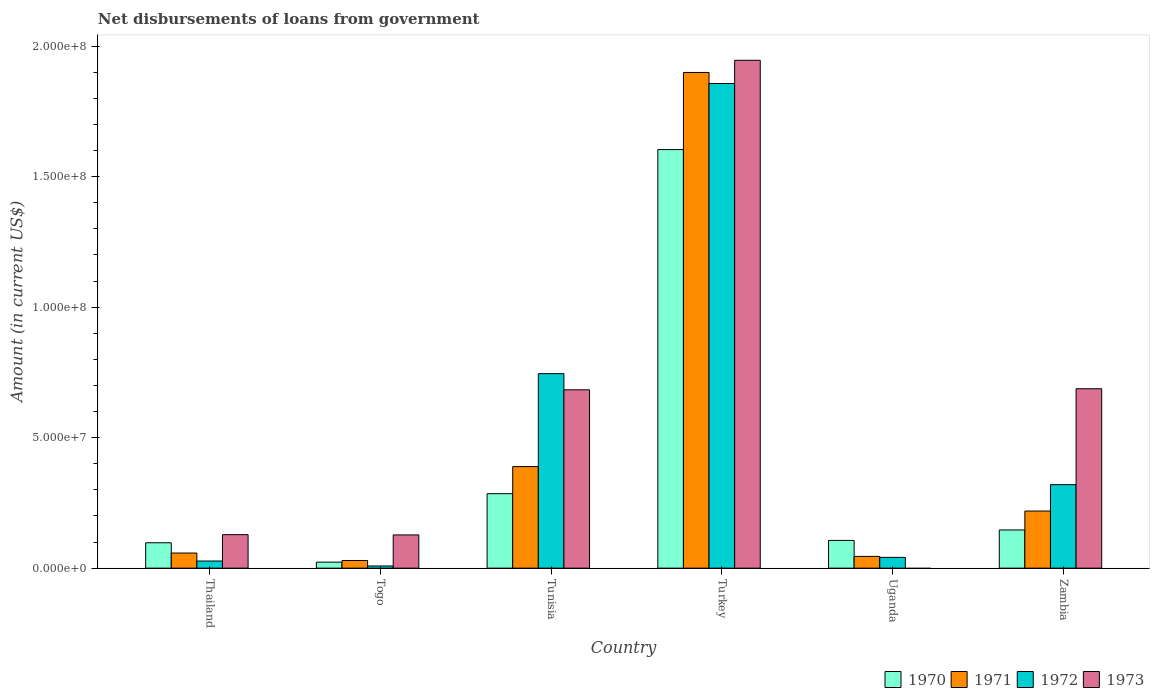How many different coloured bars are there?
Provide a short and direct response. 4. How many groups of bars are there?
Offer a terse response. 6. Are the number of bars per tick equal to the number of legend labels?
Provide a succinct answer. No. What is the label of the 6th group of bars from the left?
Make the answer very short. Zambia. What is the amount of loan disbursed from government in 1972 in Zambia?
Offer a very short reply. 3.20e+07. Across all countries, what is the maximum amount of loan disbursed from government in 1973?
Provide a succinct answer. 1.95e+08. Across all countries, what is the minimum amount of loan disbursed from government in 1970?
Provide a succinct answer. 2.30e+06. What is the total amount of loan disbursed from government in 1972 in the graph?
Provide a succinct answer. 3.00e+08. What is the difference between the amount of loan disbursed from government in 1972 in Thailand and that in Uganda?
Ensure brevity in your answer.  -1.40e+06. What is the difference between the amount of loan disbursed from government in 1971 in Togo and the amount of loan disbursed from government in 1972 in Zambia?
Provide a short and direct response. -2.91e+07. What is the average amount of loan disbursed from government in 1970 per country?
Provide a short and direct response. 3.77e+07. What is the difference between the amount of loan disbursed from government of/in 1972 and amount of loan disbursed from government of/in 1971 in Zambia?
Offer a very short reply. 1.01e+07. What is the ratio of the amount of loan disbursed from government in 1970 in Togo to that in Uganda?
Ensure brevity in your answer.  0.22. Is the difference between the amount of loan disbursed from government in 1972 in Tunisia and Zambia greater than the difference between the amount of loan disbursed from government in 1971 in Tunisia and Zambia?
Your answer should be very brief. Yes. What is the difference between the highest and the second highest amount of loan disbursed from government in 1973?
Make the answer very short. 1.26e+08. What is the difference between the highest and the lowest amount of loan disbursed from government in 1972?
Provide a succinct answer. 1.85e+08. In how many countries, is the amount of loan disbursed from government in 1971 greater than the average amount of loan disbursed from government in 1971 taken over all countries?
Keep it short and to the point. 1. Is the sum of the amount of loan disbursed from government in 1972 in Togo and Turkey greater than the maximum amount of loan disbursed from government in 1971 across all countries?
Offer a terse response. No. Is it the case that in every country, the sum of the amount of loan disbursed from government in 1971 and amount of loan disbursed from government in 1973 is greater than the sum of amount of loan disbursed from government in 1972 and amount of loan disbursed from government in 1970?
Your response must be concise. No. Is it the case that in every country, the sum of the amount of loan disbursed from government in 1972 and amount of loan disbursed from government in 1973 is greater than the amount of loan disbursed from government in 1971?
Make the answer very short. No. How many bars are there?
Keep it short and to the point. 23. How many countries are there in the graph?
Give a very brief answer. 6. Does the graph contain grids?
Ensure brevity in your answer.  No. How many legend labels are there?
Your response must be concise. 4. What is the title of the graph?
Keep it short and to the point. Net disbursements of loans from government. What is the label or title of the X-axis?
Offer a terse response. Country. What is the Amount (in current US$) in 1970 in Thailand?
Your answer should be very brief. 9.73e+06. What is the Amount (in current US$) in 1971 in Thailand?
Offer a very short reply. 5.79e+06. What is the Amount (in current US$) of 1972 in Thailand?
Provide a succinct answer. 2.73e+06. What is the Amount (in current US$) of 1973 in Thailand?
Ensure brevity in your answer.  1.28e+07. What is the Amount (in current US$) of 1970 in Togo?
Your response must be concise. 2.30e+06. What is the Amount (in current US$) of 1971 in Togo?
Provide a short and direct response. 2.94e+06. What is the Amount (in current US$) in 1972 in Togo?
Give a very brief answer. 8.31e+05. What is the Amount (in current US$) in 1973 in Togo?
Provide a succinct answer. 1.27e+07. What is the Amount (in current US$) of 1970 in Tunisia?
Your answer should be compact. 2.85e+07. What is the Amount (in current US$) in 1971 in Tunisia?
Offer a terse response. 3.89e+07. What is the Amount (in current US$) of 1972 in Tunisia?
Ensure brevity in your answer.  7.45e+07. What is the Amount (in current US$) of 1973 in Tunisia?
Provide a short and direct response. 6.83e+07. What is the Amount (in current US$) in 1970 in Turkey?
Offer a terse response. 1.60e+08. What is the Amount (in current US$) in 1971 in Turkey?
Provide a short and direct response. 1.90e+08. What is the Amount (in current US$) of 1972 in Turkey?
Keep it short and to the point. 1.86e+08. What is the Amount (in current US$) of 1973 in Turkey?
Provide a short and direct response. 1.95e+08. What is the Amount (in current US$) in 1970 in Uganda?
Provide a short and direct response. 1.06e+07. What is the Amount (in current US$) of 1971 in Uganda?
Offer a very short reply. 4.51e+06. What is the Amount (in current US$) of 1972 in Uganda?
Offer a terse response. 4.13e+06. What is the Amount (in current US$) of 1970 in Zambia?
Your answer should be compact. 1.46e+07. What is the Amount (in current US$) in 1971 in Zambia?
Your response must be concise. 2.19e+07. What is the Amount (in current US$) in 1972 in Zambia?
Provide a succinct answer. 3.20e+07. What is the Amount (in current US$) in 1973 in Zambia?
Provide a succinct answer. 6.88e+07. Across all countries, what is the maximum Amount (in current US$) of 1970?
Offer a terse response. 1.60e+08. Across all countries, what is the maximum Amount (in current US$) in 1971?
Offer a very short reply. 1.90e+08. Across all countries, what is the maximum Amount (in current US$) of 1972?
Give a very brief answer. 1.86e+08. Across all countries, what is the maximum Amount (in current US$) of 1973?
Your answer should be compact. 1.95e+08. Across all countries, what is the minimum Amount (in current US$) in 1970?
Give a very brief answer. 2.30e+06. Across all countries, what is the minimum Amount (in current US$) of 1971?
Offer a very short reply. 2.94e+06. Across all countries, what is the minimum Amount (in current US$) in 1972?
Offer a terse response. 8.31e+05. What is the total Amount (in current US$) of 1970 in the graph?
Make the answer very short. 2.26e+08. What is the total Amount (in current US$) of 1971 in the graph?
Your answer should be compact. 2.64e+08. What is the total Amount (in current US$) of 1972 in the graph?
Make the answer very short. 3.00e+08. What is the total Amount (in current US$) of 1973 in the graph?
Your answer should be very brief. 3.57e+08. What is the difference between the Amount (in current US$) of 1970 in Thailand and that in Togo?
Offer a terse response. 7.43e+06. What is the difference between the Amount (in current US$) in 1971 in Thailand and that in Togo?
Make the answer very short. 2.85e+06. What is the difference between the Amount (in current US$) of 1972 in Thailand and that in Togo?
Provide a short and direct response. 1.90e+06. What is the difference between the Amount (in current US$) of 1973 in Thailand and that in Togo?
Your answer should be very brief. 9.30e+04. What is the difference between the Amount (in current US$) of 1970 in Thailand and that in Tunisia?
Keep it short and to the point. -1.88e+07. What is the difference between the Amount (in current US$) in 1971 in Thailand and that in Tunisia?
Make the answer very short. -3.31e+07. What is the difference between the Amount (in current US$) of 1972 in Thailand and that in Tunisia?
Ensure brevity in your answer.  -7.18e+07. What is the difference between the Amount (in current US$) of 1973 in Thailand and that in Tunisia?
Your response must be concise. -5.55e+07. What is the difference between the Amount (in current US$) in 1970 in Thailand and that in Turkey?
Keep it short and to the point. -1.51e+08. What is the difference between the Amount (in current US$) in 1971 in Thailand and that in Turkey?
Your response must be concise. -1.84e+08. What is the difference between the Amount (in current US$) in 1972 in Thailand and that in Turkey?
Provide a succinct answer. -1.83e+08. What is the difference between the Amount (in current US$) of 1973 in Thailand and that in Turkey?
Your answer should be compact. -1.82e+08. What is the difference between the Amount (in current US$) in 1970 in Thailand and that in Uganda?
Provide a succinct answer. -8.97e+05. What is the difference between the Amount (in current US$) in 1971 in Thailand and that in Uganda?
Give a very brief answer. 1.28e+06. What is the difference between the Amount (in current US$) of 1972 in Thailand and that in Uganda?
Keep it short and to the point. -1.40e+06. What is the difference between the Amount (in current US$) of 1970 in Thailand and that in Zambia?
Offer a terse response. -4.90e+06. What is the difference between the Amount (in current US$) in 1971 in Thailand and that in Zambia?
Offer a very short reply. -1.61e+07. What is the difference between the Amount (in current US$) of 1972 in Thailand and that in Zambia?
Ensure brevity in your answer.  -2.93e+07. What is the difference between the Amount (in current US$) in 1973 in Thailand and that in Zambia?
Your answer should be compact. -5.59e+07. What is the difference between the Amount (in current US$) in 1970 in Togo and that in Tunisia?
Ensure brevity in your answer.  -2.62e+07. What is the difference between the Amount (in current US$) of 1971 in Togo and that in Tunisia?
Your answer should be very brief. -3.60e+07. What is the difference between the Amount (in current US$) of 1972 in Togo and that in Tunisia?
Ensure brevity in your answer.  -7.37e+07. What is the difference between the Amount (in current US$) in 1973 in Togo and that in Tunisia?
Provide a succinct answer. -5.56e+07. What is the difference between the Amount (in current US$) in 1970 in Togo and that in Turkey?
Your answer should be compact. -1.58e+08. What is the difference between the Amount (in current US$) in 1971 in Togo and that in Turkey?
Offer a terse response. -1.87e+08. What is the difference between the Amount (in current US$) in 1972 in Togo and that in Turkey?
Your response must be concise. -1.85e+08. What is the difference between the Amount (in current US$) in 1973 in Togo and that in Turkey?
Provide a succinct answer. -1.82e+08. What is the difference between the Amount (in current US$) of 1970 in Togo and that in Uganda?
Your answer should be very brief. -8.33e+06. What is the difference between the Amount (in current US$) of 1971 in Togo and that in Uganda?
Make the answer very short. -1.57e+06. What is the difference between the Amount (in current US$) in 1972 in Togo and that in Uganda?
Offer a very short reply. -3.30e+06. What is the difference between the Amount (in current US$) in 1970 in Togo and that in Zambia?
Ensure brevity in your answer.  -1.23e+07. What is the difference between the Amount (in current US$) in 1971 in Togo and that in Zambia?
Offer a terse response. -1.89e+07. What is the difference between the Amount (in current US$) in 1972 in Togo and that in Zambia?
Offer a very short reply. -3.12e+07. What is the difference between the Amount (in current US$) in 1973 in Togo and that in Zambia?
Your answer should be compact. -5.60e+07. What is the difference between the Amount (in current US$) in 1970 in Tunisia and that in Turkey?
Your answer should be compact. -1.32e+08. What is the difference between the Amount (in current US$) of 1971 in Tunisia and that in Turkey?
Make the answer very short. -1.51e+08. What is the difference between the Amount (in current US$) of 1972 in Tunisia and that in Turkey?
Offer a very short reply. -1.11e+08. What is the difference between the Amount (in current US$) in 1973 in Tunisia and that in Turkey?
Ensure brevity in your answer.  -1.26e+08. What is the difference between the Amount (in current US$) of 1970 in Tunisia and that in Uganda?
Offer a terse response. 1.79e+07. What is the difference between the Amount (in current US$) in 1971 in Tunisia and that in Uganda?
Provide a short and direct response. 3.44e+07. What is the difference between the Amount (in current US$) of 1972 in Tunisia and that in Uganda?
Your answer should be very brief. 7.04e+07. What is the difference between the Amount (in current US$) in 1970 in Tunisia and that in Zambia?
Ensure brevity in your answer.  1.39e+07. What is the difference between the Amount (in current US$) in 1971 in Tunisia and that in Zambia?
Provide a short and direct response. 1.70e+07. What is the difference between the Amount (in current US$) in 1972 in Tunisia and that in Zambia?
Offer a very short reply. 4.25e+07. What is the difference between the Amount (in current US$) of 1973 in Tunisia and that in Zambia?
Ensure brevity in your answer.  -4.12e+05. What is the difference between the Amount (in current US$) in 1970 in Turkey and that in Uganda?
Offer a very short reply. 1.50e+08. What is the difference between the Amount (in current US$) of 1971 in Turkey and that in Uganda?
Offer a very short reply. 1.85e+08. What is the difference between the Amount (in current US$) of 1972 in Turkey and that in Uganda?
Your answer should be very brief. 1.82e+08. What is the difference between the Amount (in current US$) in 1970 in Turkey and that in Zambia?
Offer a very short reply. 1.46e+08. What is the difference between the Amount (in current US$) of 1971 in Turkey and that in Zambia?
Your answer should be very brief. 1.68e+08. What is the difference between the Amount (in current US$) of 1972 in Turkey and that in Zambia?
Make the answer very short. 1.54e+08. What is the difference between the Amount (in current US$) in 1973 in Turkey and that in Zambia?
Your response must be concise. 1.26e+08. What is the difference between the Amount (in current US$) in 1970 in Uganda and that in Zambia?
Ensure brevity in your answer.  -4.01e+06. What is the difference between the Amount (in current US$) of 1971 in Uganda and that in Zambia?
Provide a succinct answer. -1.74e+07. What is the difference between the Amount (in current US$) of 1972 in Uganda and that in Zambia?
Offer a very short reply. -2.79e+07. What is the difference between the Amount (in current US$) in 1970 in Thailand and the Amount (in current US$) in 1971 in Togo?
Give a very brief answer. 6.80e+06. What is the difference between the Amount (in current US$) of 1970 in Thailand and the Amount (in current US$) of 1972 in Togo?
Offer a terse response. 8.90e+06. What is the difference between the Amount (in current US$) in 1970 in Thailand and the Amount (in current US$) in 1973 in Togo?
Provide a short and direct response. -3.00e+06. What is the difference between the Amount (in current US$) of 1971 in Thailand and the Amount (in current US$) of 1972 in Togo?
Make the answer very short. 4.96e+06. What is the difference between the Amount (in current US$) of 1971 in Thailand and the Amount (in current US$) of 1973 in Togo?
Provide a short and direct response. -6.95e+06. What is the difference between the Amount (in current US$) in 1972 in Thailand and the Amount (in current US$) in 1973 in Togo?
Your answer should be very brief. -1.00e+07. What is the difference between the Amount (in current US$) in 1970 in Thailand and the Amount (in current US$) in 1971 in Tunisia?
Offer a very short reply. -2.92e+07. What is the difference between the Amount (in current US$) of 1970 in Thailand and the Amount (in current US$) of 1972 in Tunisia?
Make the answer very short. -6.48e+07. What is the difference between the Amount (in current US$) in 1970 in Thailand and the Amount (in current US$) in 1973 in Tunisia?
Give a very brief answer. -5.86e+07. What is the difference between the Amount (in current US$) of 1971 in Thailand and the Amount (in current US$) of 1972 in Tunisia?
Your answer should be very brief. -6.87e+07. What is the difference between the Amount (in current US$) of 1971 in Thailand and the Amount (in current US$) of 1973 in Tunisia?
Offer a very short reply. -6.26e+07. What is the difference between the Amount (in current US$) of 1972 in Thailand and the Amount (in current US$) of 1973 in Tunisia?
Offer a very short reply. -6.56e+07. What is the difference between the Amount (in current US$) of 1970 in Thailand and the Amount (in current US$) of 1971 in Turkey?
Offer a very short reply. -1.80e+08. What is the difference between the Amount (in current US$) of 1970 in Thailand and the Amount (in current US$) of 1972 in Turkey?
Your answer should be very brief. -1.76e+08. What is the difference between the Amount (in current US$) of 1970 in Thailand and the Amount (in current US$) of 1973 in Turkey?
Provide a short and direct response. -1.85e+08. What is the difference between the Amount (in current US$) in 1971 in Thailand and the Amount (in current US$) in 1972 in Turkey?
Offer a terse response. -1.80e+08. What is the difference between the Amount (in current US$) of 1971 in Thailand and the Amount (in current US$) of 1973 in Turkey?
Offer a terse response. -1.89e+08. What is the difference between the Amount (in current US$) of 1972 in Thailand and the Amount (in current US$) of 1973 in Turkey?
Offer a very short reply. -1.92e+08. What is the difference between the Amount (in current US$) in 1970 in Thailand and the Amount (in current US$) in 1971 in Uganda?
Give a very brief answer. 5.22e+06. What is the difference between the Amount (in current US$) of 1970 in Thailand and the Amount (in current US$) of 1972 in Uganda?
Your answer should be very brief. 5.60e+06. What is the difference between the Amount (in current US$) of 1971 in Thailand and the Amount (in current US$) of 1972 in Uganda?
Provide a succinct answer. 1.66e+06. What is the difference between the Amount (in current US$) in 1970 in Thailand and the Amount (in current US$) in 1971 in Zambia?
Make the answer very short. -1.22e+07. What is the difference between the Amount (in current US$) of 1970 in Thailand and the Amount (in current US$) of 1972 in Zambia?
Make the answer very short. -2.23e+07. What is the difference between the Amount (in current US$) of 1970 in Thailand and the Amount (in current US$) of 1973 in Zambia?
Keep it short and to the point. -5.90e+07. What is the difference between the Amount (in current US$) of 1971 in Thailand and the Amount (in current US$) of 1972 in Zambia?
Make the answer very short. -2.62e+07. What is the difference between the Amount (in current US$) of 1971 in Thailand and the Amount (in current US$) of 1973 in Zambia?
Provide a succinct answer. -6.30e+07. What is the difference between the Amount (in current US$) in 1972 in Thailand and the Amount (in current US$) in 1973 in Zambia?
Provide a short and direct response. -6.60e+07. What is the difference between the Amount (in current US$) of 1970 in Togo and the Amount (in current US$) of 1971 in Tunisia?
Offer a very short reply. -3.66e+07. What is the difference between the Amount (in current US$) of 1970 in Togo and the Amount (in current US$) of 1972 in Tunisia?
Keep it short and to the point. -7.22e+07. What is the difference between the Amount (in current US$) in 1970 in Togo and the Amount (in current US$) in 1973 in Tunisia?
Your response must be concise. -6.60e+07. What is the difference between the Amount (in current US$) in 1971 in Togo and the Amount (in current US$) in 1972 in Tunisia?
Offer a very short reply. -7.16e+07. What is the difference between the Amount (in current US$) of 1971 in Togo and the Amount (in current US$) of 1973 in Tunisia?
Give a very brief answer. -6.54e+07. What is the difference between the Amount (in current US$) of 1972 in Togo and the Amount (in current US$) of 1973 in Tunisia?
Offer a terse response. -6.75e+07. What is the difference between the Amount (in current US$) of 1970 in Togo and the Amount (in current US$) of 1971 in Turkey?
Provide a short and direct response. -1.88e+08. What is the difference between the Amount (in current US$) in 1970 in Togo and the Amount (in current US$) in 1972 in Turkey?
Ensure brevity in your answer.  -1.83e+08. What is the difference between the Amount (in current US$) of 1970 in Togo and the Amount (in current US$) of 1973 in Turkey?
Offer a terse response. -1.92e+08. What is the difference between the Amount (in current US$) of 1971 in Togo and the Amount (in current US$) of 1972 in Turkey?
Make the answer very short. -1.83e+08. What is the difference between the Amount (in current US$) in 1971 in Togo and the Amount (in current US$) in 1973 in Turkey?
Provide a short and direct response. -1.92e+08. What is the difference between the Amount (in current US$) of 1972 in Togo and the Amount (in current US$) of 1973 in Turkey?
Your answer should be very brief. -1.94e+08. What is the difference between the Amount (in current US$) in 1970 in Togo and the Amount (in current US$) in 1971 in Uganda?
Ensure brevity in your answer.  -2.21e+06. What is the difference between the Amount (in current US$) in 1970 in Togo and the Amount (in current US$) in 1972 in Uganda?
Offer a very short reply. -1.83e+06. What is the difference between the Amount (in current US$) of 1971 in Togo and the Amount (in current US$) of 1972 in Uganda?
Give a very brief answer. -1.20e+06. What is the difference between the Amount (in current US$) of 1970 in Togo and the Amount (in current US$) of 1971 in Zambia?
Make the answer very short. -1.96e+07. What is the difference between the Amount (in current US$) in 1970 in Togo and the Amount (in current US$) in 1972 in Zambia?
Provide a succinct answer. -2.97e+07. What is the difference between the Amount (in current US$) in 1970 in Togo and the Amount (in current US$) in 1973 in Zambia?
Give a very brief answer. -6.65e+07. What is the difference between the Amount (in current US$) of 1971 in Togo and the Amount (in current US$) of 1972 in Zambia?
Offer a very short reply. -2.91e+07. What is the difference between the Amount (in current US$) in 1971 in Togo and the Amount (in current US$) in 1973 in Zambia?
Ensure brevity in your answer.  -6.58e+07. What is the difference between the Amount (in current US$) in 1972 in Togo and the Amount (in current US$) in 1973 in Zambia?
Make the answer very short. -6.79e+07. What is the difference between the Amount (in current US$) in 1970 in Tunisia and the Amount (in current US$) in 1971 in Turkey?
Make the answer very short. -1.61e+08. What is the difference between the Amount (in current US$) of 1970 in Tunisia and the Amount (in current US$) of 1972 in Turkey?
Offer a terse response. -1.57e+08. What is the difference between the Amount (in current US$) of 1970 in Tunisia and the Amount (in current US$) of 1973 in Turkey?
Make the answer very short. -1.66e+08. What is the difference between the Amount (in current US$) of 1971 in Tunisia and the Amount (in current US$) of 1972 in Turkey?
Provide a short and direct response. -1.47e+08. What is the difference between the Amount (in current US$) in 1971 in Tunisia and the Amount (in current US$) in 1973 in Turkey?
Your response must be concise. -1.56e+08. What is the difference between the Amount (in current US$) in 1972 in Tunisia and the Amount (in current US$) in 1973 in Turkey?
Ensure brevity in your answer.  -1.20e+08. What is the difference between the Amount (in current US$) in 1970 in Tunisia and the Amount (in current US$) in 1971 in Uganda?
Keep it short and to the point. 2.40e+07. What is the difference between the Amount (in current US$) of 1970 in Tunisia and the Amount (in current US$) of 1972 in Uganda?
Give a very brief answer. 2.44e+07. What is the difference between the Amount (in current US$) of 1971 in Tunisia and the Amount (in current US$) of 1972 in Uganda?
Offer a terse response. 3.48e+07. What is the difference between the Amount (in current US$) of 1970 in Tunisia and the Amount (in current US$) of 1971 in Zambia?
Offer a terse response. 6.66e+06. What is the difference between the Amount (in current US$) in 1970 in Tunisia and the Amount (in current US$) in 1972 in Zambia?
Offer a very short reply. -3.46e+06. What is the difference between the Amount (in current US$) in 1970 in Tunisia and the Amount (in current US$) in 1973 in Zambia?
Your answer should be compact. -4.02e+07. What is the difference between the Amount (in current US$) of 1971 in Tunisia and the Amount (in current US$) of 1972 in Zambia?
Make the answer very short. 6.92e+06. What is the difference between the Amount (in current US$) of 1971 in Tunisia and the Amount (in current US$) of 1973 in Zambia?
Offer a terse response. -2.98e+07. What is the difference between the Amount (in current US$) of 1972 in Tunisia and the Amount (in current US$) of 1973 in Zambia?
Your response must be concise. 5.78e+06. What is the difference between the Amount (in current US$) in 1970 in Turkey and the Amount (in current US$) in 1971 in Uganda?
Provide a succinct answer. 1.56e+08. What is the difference between the Amount (in current US$) in 1970 in Turkey and the Amount (in current US$) in 1972 in Uganda?
Make the answer very short. 1.56e+08. What is the difference between the Amount (in current US$) in 1971 in Turkey and the Amount (in current US$) in 1972 in Uganda?
Your response must be concise. 1.86e+08. What is the difference between the Amount (in current US$) of 1970 in Turkey and the Amount (in current US$) of 1971 in Zambia?
Ensure brevity in your answer.  1.39e+08. What is the difference between the Amount (in current US$) in 1970 in Turkey and the Amount (in current US$) in 1972 in Zambia?
Provide a short and direct response. 1.28e+08. What is the difference between the Amount (in current US$) of 1970 in Turkey and the Amount (in current US$) of 1973 in Zambia?
Provide a short and direct response. 9.16e+07. What is the difference between the Amount (in current US$) of 1971 in Turkey and the Amount (in current US$) of 1972 in Zambia?
Your answer should be very brief. 1.58e+08. What is the difference between the Amount (in current US$) in 1971 in Turkey and the Amount (in current US$) in 1973 in Zambia?
Give a very brief answer. 1.21e+08. What is the difference between the Amount (in current US$) in 1972 in Turkey and the Amount (in current US$) in 1973 in Zambia?
Provide a short and direct response. 1.17e+08. What is the difference between the Amount (in current US$) of 1970 in Uganda and the Amount (in current US$) of 1971 in Zambia?
Make the answer very short. -1.13e+07. What is the difference between the Amount (in current US$) in 1970 in Uganda and the Amount (in current US$) in 1972 in Zambia?
Ensure brevity in your answer.  -2.14e+07. What is the difference between the Amount (in current US$) of 1970 in Uganda and the Amount (in current US$) of 1973 in Zambia?
Your answer should be very brief. -5.81e+07. What is the difference between the Amount (in current US$) in 1971 in Uganda and the Amount (in current US$) in 1972 in Zambia?
Your answer should be compact. -2.75e+07. What is the difference between the Amount (in current US$) in 1971 in Uganda and the Amount (in current US$) in 1973 in Zambia?
Your answer should be very brief. -6.42e+07. What is the difference between the Amount (in current US$) in 1972 in Uganda and the Amount (in current US$) in 1973 in Zambia?
Ensure brevity in your answer.  -6.46e+07. What is the average Amount (in current US$) of 1970 per country?
Provide a succinct answer. 3.77e+07. What is the average Amount (in current US$) in 1971 per country?
Make the answer very short. 4.40e+07. What is the average Amount (in current US$) in 1972 per country?
Your response must be concise. 5.00e+07. What is the average Amount (in current US$) in 1973 per country?
Offer a terse response. 5.95e+07. What is the difference between the Amount (in current US$) in 1970 and Amount (in current US$) in 1971 in Thailand?
Give a very brief answer. 3.94e+06. What is the difference between the Amount (in current US$) of 1970 and Amount (in current US$) of 1972 in Thailand?
Provide a short and direct response. 7.00e+06. What is the difference between the Amount (in current US$) of 1970 and Amount (in current US$) of 1973 in Thailand?
Your answer should be very brief. -3.10e+06. What is the difference between the Amount (in current US$) in 1971 and Amount (in current US$) in 1972 in Thailand?
Make the answer very short. 3.06e+06. What is the difference between the Amount (in current US$) in 1971 and Amount (in current US$) in 1973 in Thailand?
Your response must be concise. -7.04e+06. What is the difference between the Amount (in current US$) of 1972 and Amount (in current US$) of 1973 in Thailand?
Ensure brevity in your answer.  -1.01e+07. What is the difference between the Amount (in current US$) of 1970 and Amount (in current US$) of 1971 in Togo?
Your answer should be compact. -6.37e+05. What is the difference between the Amount (in current US$) in 1970 and Amount (in current US$) in 1972 in Togo?
Give a very brief answer. 1.47e+06. What is the difference between the Amount (in current US$) of 1970 and Amount (in current US$) of 1973 in Togo?
Your answer should be very brief. -1.04e+07. What is the difference between the Amount (in current US$) in 1971 and Amount (in current US$) in 1972 in Togo?
Keep it short and to the point. 2.10e+06. What is the difference between the Amount (in current US$) in 1971 and Amount (in current US$) in 1973 in Togo?
Offer a very short reply. -9.80e+06. What is the difference between the Amount (in current US$) of 1972 and Amount (in current US$) of 1973 in Togo?
Your answer should be compact. -1.19e+07. What is the difference between the Amount (in current US$) in 1970 and Amount (in current US$) in 1971 in Tunisia?
Your response must be concise. -1.04e+07. What is the difference between the Amount (in current US$) of 1970 and Amount (in current US$) of 1972 in Tunisia?
Provide a short and direct response. -4.60e+07. What is the difference between the Amount (in current US$) in 1970 and Amount (in current US$) in 1973 in Tunisia?
Your response must be concise. -3.98e+07. What is the difference between the Amount (in current US$) of 1971 and Amount (in current US$) of 1972 in Tunisia?
Make the answer very short. -3.56e+07. What is the difference between the Amount (in current US$) of 1971 and Amount (in current US$) of 1973 in Tunisia?
Your answer should be very brief. -2.94e+07. What is the difference between the Amount (in current US$) in 1972 and Amount (in current US$) in 1973 in Tunisia?
Your answer should be compact. 6.20e+06. What is the difference between the Amount (in current US$) in 1970 and Amount (in current US$) in 1971 in Turkey?
Keep it short and to the point. -2.95e+07. What is the difference between the Amount (in current US$) of 1970 and Amount (in current US$) of 1972 in Turkey?
Your response must be concise. -2.53e+07. What is the difference between the Amount (in current US$) in 1970 and Amount (in current US$) in 1973 in Turkey?
Make the answer very short. -3.42e+07. What is the difference between the Amount (in current US$) in 1971 and Amount (in current US$) in 1972 in Turkey?
Keep it short and to the point. 4.24e+06. What is the difference between the Amount (in current US$) in 1971 and Amount (in current US$) in 1973 in Turkey?
Provide a succinct answer. -4.67e+06. What is the difference between the Amount (in current US$) of 1972 and Amount (in current US$) of 1973 in Turkey?
Make the answer very short. -8.91e+06. What is the difference between the Amount (in current US$) of 1970 and Amount (in current US$) of 1971 in Uganda?
Offer a terse response. 6.12e+06. What is the difference between the Amount (in current US$) of 1970 and Amount (in current US$) of 1972 in Uganda?
Offer a terse response. 6.50e+06. What is the difference between the Amount (in current US$) of 1971 and Amount (in current US$) of 1972 in Uganda?
Give a very brief answer. 3.77e+05. What is the difference between the Amount (in current US$) of 1970 and Amount (in current US$) of 1971 in Zambia?
Your answer should be very brief. -7.25e+06. What is the difference between the Amount (in current US$) of 1970 and Amount (in current US$) of 1972 in Zambia?
Offer a very short reply. -1.74e+07. What is the difference between the Amount (in current US$) in 1970 and Amount (in current US$) in 1973 in Zambia?
Keep it short and to the point. -5.41e+07. What is the difference between the Amount (in current US$) of 1971 and Amount (in current US$) of 1972 in Zambia?
Provide a succinct answer. -1.01e+07. What is the difference between the Amount (in current US$) of 1971 and Amount (in current US$) of 1973 in Zambia?
Keep it short and to the point. -4.69e+07. What is the difference between the Amount (in current US$) in 1972 and Amount (in current US$) in 1973 in Zambia?
Provide a short and direct response. -3.68e+07. What is the ratio of the Amount (in current US$) in 1970 in Thailand to that in Togo?
Your answer should be compact. 4.24. What is the ratio of the Amount (in current US$) in 1971 in Thailand to that in Togo?
Make the answer very short. 1.97. What is the ratio of the Amount (in current US$) of 1972 in Thailand to that in Togo?
Your answer should be very brief. 3.29. What is the ratio of the Amount (in current US$) of 1973 in Thailand to that in Togo?
Make the answer very short. 1.01. What is the ratio of the Amount (in current US$) of 1970 in Thailand to that in Tunisia?
Give a very brief answer. 0.34. What is the ratio of the Amount (in current US$) in 1971 in Thailand to that in Tunisia?
Give a very brief answer. 0.15. What is the ratio of the Amount (in current US$) in 1972 in Thailand to that in Tunisia?
Your answer should be compact. 0.04. What is the ratio of the Amount (in current US$) in 1973 in Thailand to that in Tunisia?
Make the answer very short. 0.19. What is the ratio of the Amount (in current US$) in 1970 in Thailand to that in Turkey?
Your answer should be very brief. 0.06. What is the ratio of the Amount (in current US$) of 1971 in Thailand to that in Turkey?
Keep it short and to the point. 0.03. What is the ratio of the Amount (in current US$) in 1972 in Thailand to that in Turkey?
Offer a terse response. 0.01. What is the ratio of the Amount (in current US$) in 1973 in Thailand to that in Turkey?
Your response must be concise. 0.07. What is the ratio of the Amount (in current US$) in 1970 in Thailand to that in Uganda?
Your response must be concise. 0.92. What is the ratio of the Amount (in current US$) in 1971 in Thailand to that in Uganda?
Make the answer very short. 1.28. What is the ratio of the Amount (in current US$) of 1972 in Thailand to that in Uganda?
Your answer should be compact. 0.66. What is the ratio of the Amount (in current US$) in 1970 in Thailand to that in Zambia?
Your answer should be compact. 0.66. What is the ratio of the Amount (in current US$) of 1971 in Thailand to that in Zambia?
Offer a very short reply. 0.26. What is the ratio of the Amount (in current US$) of 1972 in Thailand to that in Zambia?
Make the answer very short. 0.09. What is the ratio of the Amount (in current US$) of 1973 in Thailand to that in Zambia?
Keep it short and to the point. 0.19. What is the ratio of the Amount (in current US$) in 1970 in Togo to that in Tunisia?
Ensure brevity in your answer.  0.08. What is the ratio of the Amount (in current US$) of 1971 in Togo to that in Tunisia?
Ensure brevity in your answer.  0.08. What is the ratio of the Amount (in current US$) of 1972 in Togo to that in Tunisia?
Your response must be concise. 0.01. What is the ratio of the Amount (in current US$) in 1973 in Togo to that in Tunisia?
Offer a very short reply. 0.19. What is the ratio of the Amount (in current US$) in 1970 in Togo to that in Turkey?
Keep it short and to the point. 0.01. What is the ratio of the Amount (in current US$) in 1971 in Togo to that in Turkey?
Your answer should be compact. 0.02. What is the ratio of the Amount (in current US$) in 1972 in Togo to that in Turkey?
Your answer should be very brief. 0. What is the ratio of the Amount (in current US$) of 1973 in Togo to that in Turkey?
Provide a succinct answer. 0.07. What is the ratio of the Amount (in current US$) in 1970 in Togo to that in Uganda?
Give a very brief answer. 0.22. What is the ratio of the Amount (in current US$) in 1971 in Togo to that in Uganda?
Your answer should be compact. 0.65. What is the ratio of the Amount (in current US$) in 1972 in Togo to that in Uganda?
Make the answer very short. 0.2. What is the ratio of the Amount (in current US$) of 1970 in Togo to that in Zambia?
Offer a very short reply. 0.16. What is the ratio of the Amount (in current US$) in 1971 in Togo to that in Zambia?
Your response must be concise. 0.13. What is the ratio of the Amount (in current US$) of 1972 in Togo to that in Zambia?
Provide a short and direct response. 0.03. What is the ratio of the Amount (in current US$) of 1973 in Togo to that in Zambia?
Provide a succinct answer. 0.19. What is the ratio of the Amount (in current US$) of 1970 in Tunisia to that in Turkey?
Make the answer very short. 0.18. What is the ratio of the Amount (in current US$) in 1971 in Tunisia to that in Turkey?
Your answer should be compact. 0.2. What is the ratio of the Amount (in current US$) in 1972 in Tunisia to that in Turkey?
Offer a terse response. 0.4. What is the ratio of the Amount (in current US$) of 1973 in Tunisia to that in Turkey?
Ensure brevity in your answer.  0.35. What is the ratio of the Amount (in current US$) of 1970 in Tunisia to that in Uganda?
Your answer should be compact. 2.68. What is the ratio of the Amount (in current US$) in 1971 in Tunisia to that in Uganda?
Give a very brief answer. 8.64. What is the ratio of the Amount (in current US$) in 1972 in Tunisia to that in Uganda?
Make the answer very short. 18.05. What is the ratio of the Amount (in current US$) of 1970 in Tunisia to that in Zambia?
Your response must be concise. 1.95. What is the ratio of the Amount (in current US$) of 1971 in Tunisia to that in Zambia?
Your answer should be very brief. 1.78. What is the ratio of the Amount (in current US$) of 1972 in Tunisia to that in Zambia?
Offer a very short reply. 2.33. What is the ratio of the Amount (in current US$) in 1970 in Turkey to that in Uganda?
Make the answer very short. 15.09. What is the ratio of the Amount (in current US$) in 1971 in Turkey to that in Uganda?
Your answer should be compact. 42.14. What is the ratio of the Amount (in current US$) of 1972 in Turkey to that in Uganda?
Your answer should be compact. 44.97. What is the ratio of the Amount (in current US$) in 1970 in Turkey to that in Zambia?
Provide a short and direct response. 10.96. What is the ratio of the Amount (in current US$) in 1971 in Turkey to that in Zambia?
Your answer should be compact. 8.68. What is the ratio of the Amount (in current US$) in 1972 in Turkey to that in Zambia?
Provide a short and direct response. 5.8. What is the ratio of the Amount (in current US$) in 1973 in Turkey to that in Zambia?
Provide a short and direct response. 2.83. What is the ratio of the Amount (in current US$) in 1970 in Uganda to that in Zambia?
Your answer should be compact. 0.73. What is the ratio of the Amount (in current US$) of 1971 in Uganda to that in Zambia?
Your answer should be compact. 0.21. What is the ratio of the Amount (in current US$) in 1972 in Uganda to that in Zambia?
Provide a short and direct response. 0.13. What is the difference between the highest and the second highest Amount (in current US$) of 1970?
Your response must be concise. 1.32e+08. What is the difference between the highest and the second highest Amount (in current US$) of 1971?
Give a very brief answer. 1.51e+08. What is the difference between the highest and the second highest Amount (in current US$) of 1972?
Your answer should be compact. 1.11e+08. What is the difference between the highest and the second highest Amount (in current US$) of 1973?
Keep it short and to the point. 1.26e+08. What is the difference between the highest and the lowest Amount (in current US$) of 1970?
Make the answer very short. 1.58e+08. What is the difference between the highest and the lowest Amount (in current US$) in 1971?
Make the answer very short. 1.87e+08. What is the difference between the highest and the lowest Amount (in current US$) in 1972?
Your answer should be very brief. 1.85e+08. What is the difference between the highest and the lowest Amount (in current US$) of 1973?
Provide a succinct answer. 1.95e+08. 